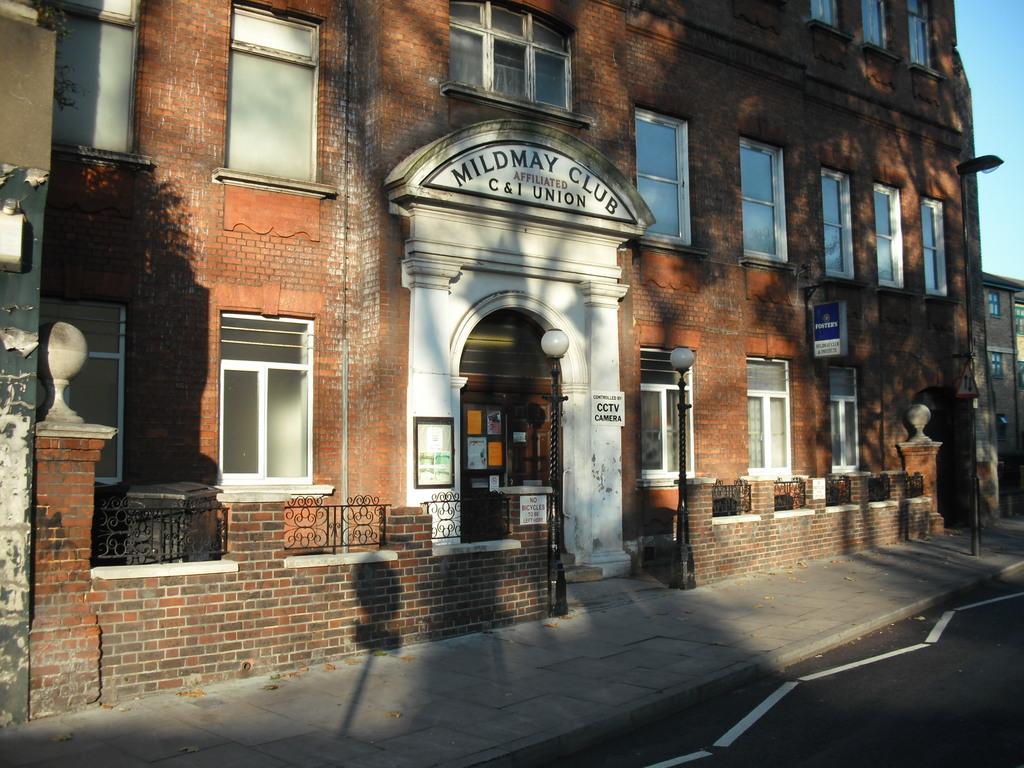Describe this image in one or two sentences. In this image in the center there is building and in front of the building there are poles and there is a fence and there is a board with some text written on it. On the building there is some text on it. On the right side of the building there is a building and the sky is cloudy. 